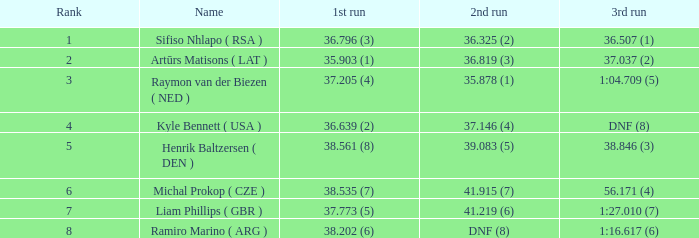Which third attempt has a ranking of 1? 36.507 (1). 